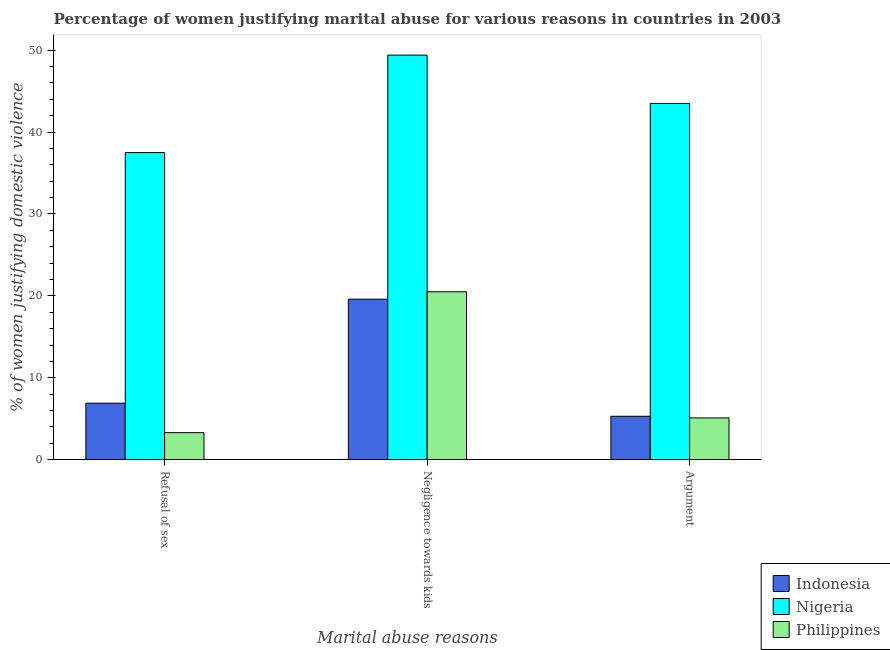How many different coloured bars are there?
Make the answer very short. 3. How many groups of bars are there?
Make the answer very short. 3. Are the number of bars on each tick of the X-axis equal?
Offer a terse response. Yes. How many bars are there on the 2nd tick from the left?
Make the answer very short. 3. What is the label of the 2nd group of bars from the left?
Offer a very short reply. Negligence towards kids. What is the percentage of women justifying domestic violence due to arguments in Indonesia?
Offer a very short reply. 5.3. Across all countries, what is the maximum percentage of women justifying domestic violence due to arguments?
Make the answer very short. 43.5. In which country was the percentage of women justifying domestic violence due to arguments maximum?
Offer a very short reply. Nigeria. In which country was the percentage of women justifying domestic violence due to arguments minimum?
Give a very brief answer. Philippines. What is the total percentage of women justifying domestic violence due to arguments in the graph?
Your answer should be very brief. 53.9. What is the difference between the percentage of women justifying domestic violence due to refusal of sex in Philippines and that in Indonesia?
Provide a short and direct response. -3.6. What is the difference between the percentage of women justifying domestic violence due to negligence towards kids in Nigeria and the percentage of women justifying domestic violence due to arguments in Philippines?
Your response must be concise. 44.3. What is the average percentage of women justifying domestic violence due to refusal of sex per country?
Offer a very short reply. 15.9. What is the difference between the percentage of women justifying domestic violence due to refusal of sex and percentage of women justifying domestic violence due to arguments in Indonesia?
Provide a short and direct response. 1.6. What is the ratio of the percentage of women justifying domestic violence due to refusal of sex in Indonesia to that in Philippines?
Make the answer very short. 2.09. What is the difference between the highest and the second highest percentage of women justifying domestic violence due to arguments?
Your answer should be compact. 38.2. What is the difference between the highest and the lowest percentage of women justifying domestic violence due to negligence towards kids?
Provide a short and direct response. 29.8. What does the 2nd bar from the left in Negligence towards kids represents?
Ensure brevity in your answer.  Nigeria. Is it the case that in every country, the sum of the percentage of women justifying domestic violence due to refusal of sex and percentage of women justifying domestic violence due to negligence towards kids is greater than the percentage of women justifying domestic violence due to arguments?
Ensure brevity in your answer.  Yes. How many bars are there?
Make the answer very short. 9. What is the difference between two consecutive major ticks on the Y-axis?
Provide a short and direct response. 10. Are the values on the major ticks of Y-axis written in scientific E-notation?
Your answer should be compact. No. Does the graph contain grids?
Your response must be concise. No. Where does the legend appear in the graph?
Your answer should be compact. Bottom right. What is the title of the graph?
Your answer should be compact. Percentage of women justifying marital abuse for various reasons in countries in 2003. What is the label or title of the X-axis?
Give a very brief answer. Marital abuse reasons. What is the label or title of the Y-axis?
Give a very brief answer. % of women justifying domestic violence. What is the % of women justifying domestic violence of Indonesia in Refusal of sex?
Keep it short and to the point. 6.9. What is the % of women justifying domestic violence of Nigeria in Refusal of sex?
Make the answer very short. 37.5. What is the % of women justifying domestic violence of Philippines in Refusal of sex?
Your answer should be compact. 3.3. What is the % of women justifying domestic violence of Indonesia in Negligence towards kids?
Your answer should be compact. 19.6. What is the % of women justifying domestic violence in Nigeria in Negligence towards kids?
Offer a very short reply. 49.4. What is the % of women justifying domestic violence of Philippines in Negligence towards kids?
Your answer should be very brief. 20.5. What is the % of women justifying domestic violence in Nigeria in Argument?
Offer a terse response. 43.5. Across all Marital abuse reasons, what is the maximum % of women justifying domestic violence in Indonesia?
Provide a short and direct response. 19.6. Across all Marital abuse reasons, what is the maximum % of women justifying domestic violence of Nigeria?
Your answer should be very brief. 49.4. Across all Marital abuse reasons, what is the minimum % of women justifying domestic violence in Nigeria?
Your response must be concise. 37.5. What is the total % of women justifying domestic violence in Indonesia in the graph?
Make the answer very short. 31.8. What is the total % of women justifying domestic violence in Nigeria in the graph?
Offer a very short reply. 130.4. What is the total % of women justifying domestic violence of Philippines in the graph?
Provide a succinct answer. 28.9. What is the difference between the % of women justifying domestic violence of Philippines in Refusal of sex and that in Negligence towards kids?
Provide a short and direct response. -17.2. What is the difference between the % of women justifying domestic violence of Philippines in Negligence towards kids and that in Argument?
Make the answer very short. 15.4. What is the difference between the % of women justifying domestic violence of Indonesia in Refusal of sex and the % of women justifying domestic violence of Nigeria in Negligence towards kids?
Give a very brief answer. -42.5. What is the difference between the % of women justifying domestic violence of Nigeria in Refusal of sex and the % of women justifying domestic violence of Philippines in Negligence towards kids?
Give a very brief answer. 17. What is the difference between the % of women justifying domestic violence of Indonesia in Refusal of sex and the % of women justifying domestic violence of Nigeria in Argument?
Provide a short and direct response. -36.6. What is the difference between the % of women justifying domestic violence in Nigeria in Refusal of sex and the % of women justifying domestic violence in Philippines in Argument?
Provide a succinct answer. 32.4. What is the difference between the % of women justifying domestic violence in Indonesia in Negligence towards kids and the % of women justifying domestic violence in Nigeria in Argument?
Offer a very short reply. -23.9. What is the difference between the % of women justifying domestic violence in Indonesia in Negligence towards kids and the % of women justifying domestic violence in Philippines in Argument?
Your response must be concise. 14.5. What is the difference between the % of women justifying domestic violence in Nigeria in Negligence towards kids and the % of women justifying domestic violence in Philippines in Argument?
Offer a very short reply. 44.3. What is the average % of women justifying domestic violence in Nigeria per Marital abuse reasons?
Give a very brief answer. 43.47. What is the average % of women justifying domestic violence of Philippines per Marital abuse reasons?
Keep it short and to the point. 9.63. What is the difference between the % of women justifying domestic violence in Indonesia and % of women justifying domestic violence in Nigeria in Refusal of sex?
Ensure brevity in your answer.  -30.6. What is the difference between the % of women justifying domestic violence of Indonesia and % of women justifying domestic violence of Philippines in Refusal of sex?
Your answer should be very brief. 3.6. What is the difference between the % of women justifying domestic violence of Nigeria and % of women justifying domestic violence of Philippines in Refusal of sex?
Your response must be concise. 34.2. What is the difference between the % of women justifying domestic violence of Indonesia and % of women justifying domestic violence of Nigeria in Negligence towards kids?
Your answer should be very brief. -29.8. What is the difference between the % of women justifying domestic violence of Indonesia and % of women justifying domestic violence of Philippines in Negligence towards kids?
Keep it short and to the point. -0.9. What is the difference between the % of women justifying domestic violence in Nigeria and % of women justifying domestic violence in Philippines in Negligence towards kids?
Your answer should be compact. 28.9. What is the difference between the % of women justifying domestic violence of Indonesia and % of women justifying domestic violence of Nigeria in Argument?
Your answer should be compact. -38.2. What is the difference between the % of women justifying domestic violence of Indonesia and % of women justifying domestic violence of Philippines in Argument?
Ensure brevity in your answer.  0.2. What is the difference between the % of women justifying domestic violence of Nigeria and % of women justifying domestic violence of Philippines in Argument?
Your response must be concise. 38.4. What is the ratio of the % of women justifying domestic violence of Indonesia in Refusal of sex to that in Negligence towards kids?
Make the answer very short. 0.35. What is the ratio of the % of women justifying domestic violence in Nigeria in Refusal of sex to that in Negligence towards kids?
Offer a terse response. 0.76. What is the ratio of the % of women justifying domestic violence of Philippines in Refusal of sex to that in Negligence towards kids?
Offer a very short reply. 0.16. What is the ratio of the % of women justifying domestic violence in Indonesia in Refusal of sex to that in Argument?
Give a very brief answer. 1.3. What is the ratio of the % of women justifying domestic violence in Nigeria in Refusal of sex to that in Argument?
Keep it short and to the point. 0.86. What is the ratio of the % of women justifying domestic violence of Philippines in Refusal of sex to that in Argument?
Your answer should be compact. 0.65. What is the ratio of the % of women justifying domestic violence in Indonesia in Negligence towards kids to that in Argument?
Make the answer very short. 3.7. What is the ratio of the % of women justifying domestic violence of Nigeria in Negligence towards kids to that in Argument?
Ensure brevity in your answer.  1.14. What is the ratio of the % of women justifying domestic violence of Philippines in Negligence towards kids to that in Argument?
Keep it short and to the point. 4.02. What is the difference between the highest and the second highest % of women justifying domestic violence in Nigeria?
Offer a terse response. 5.9. What is the difference between the highest and the lowest % of women justifying domestic violence of Indonesia?
Your answer should be compact. 14.3. What is the difference between the highest and the lowest % of women justifying domestic violence in Nigeria?
Provide a short and direct response. 11.9. What is the difference between the highest and the lowest % of women justifying domestic violence of Philippines?
Give a very brief answer. 17.2. 